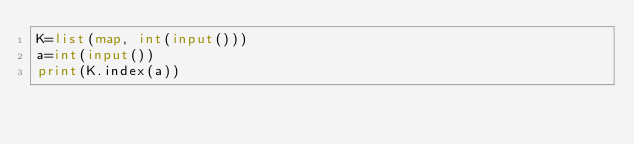Convert code to text. <code><loc_0><loc_0><loc_500><loc_500><_Python_>K=list(map, int(input()))
a=int(input())
print(K.index(a))
</code> 